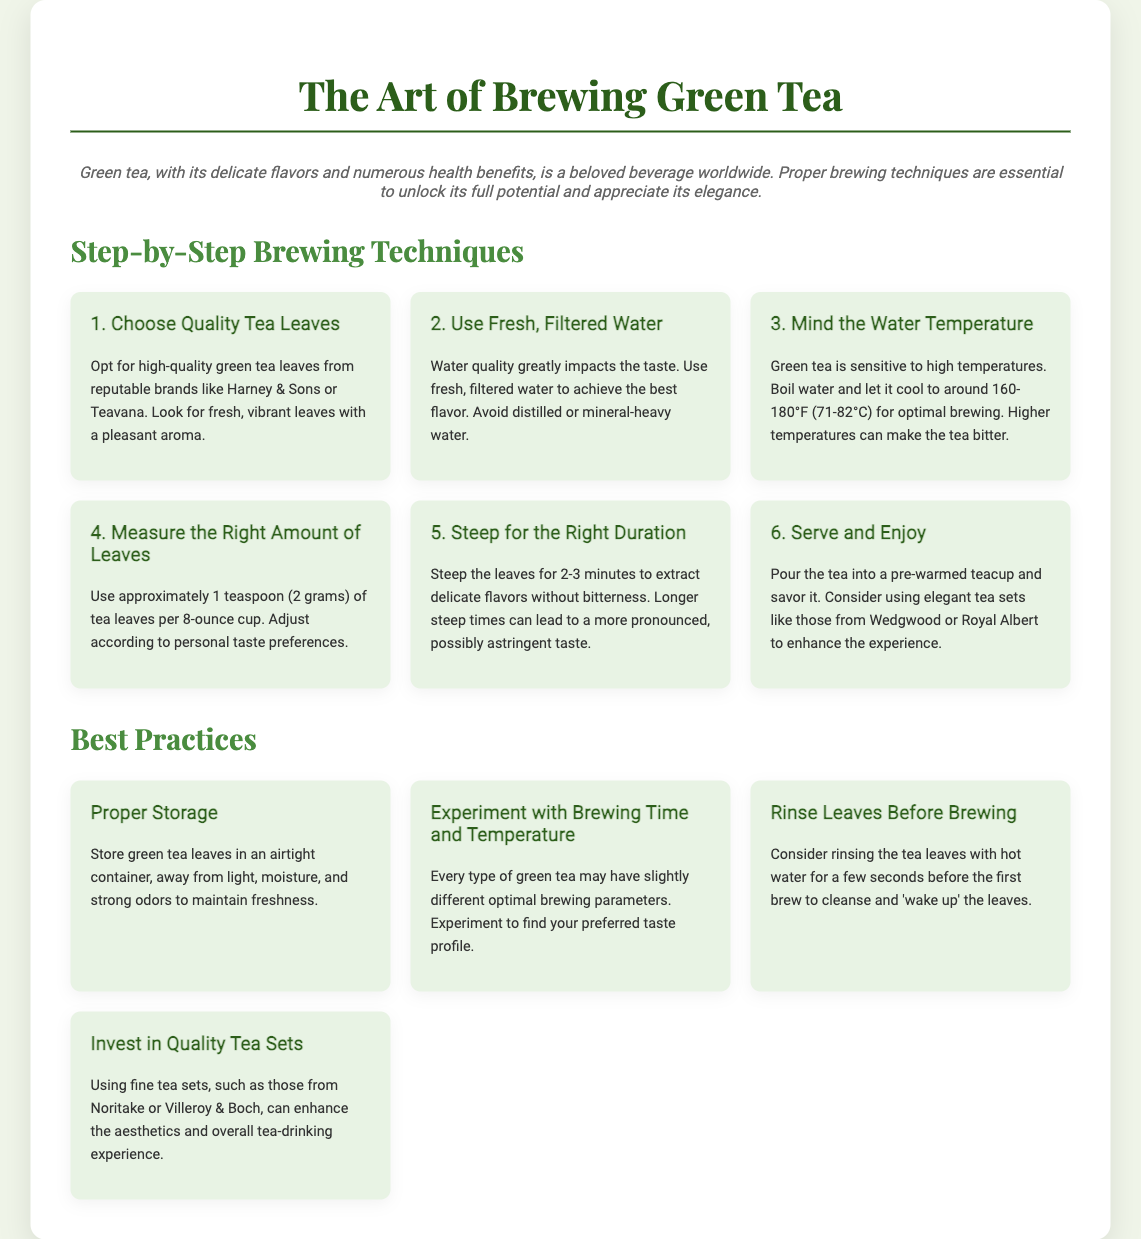What is the ideal water temperature for brewing green tea? The document states that the optimal water temperature for brewing green tea is around 160-180°F (71-82°C).
Answer: 160-180°F (71-82°C) How many grams of tea leaves should be used per 8-ounce cup? According to the document, approximately 1 teaspoon (2 grams) of tea leaves should be used per 8-ounce cup.
Answer: 2 grams What is one brand recommended for quality green tea leaves? The presentation mentions reputable brands such as Harney & Sons or Teavana as options for quality green tea leaves.
Answer: Harney & Sons What should you use to enhance the aesthetics of the tea-drinking experience? The document suggests using fine tea sets, like those from Noritake or Villeroy & Boch, to enhance the overall experience.
Answer: Fine tea sets What is one of the best practices for storing green tea leaves? The document advises storing green tea leaves in an airtight container, away from light, moisture, and strong odors to maintain freshness.
Answer: Airtight container What effect does a longer steep time have on green tea? The document indicates that longer steep times can lead to a more pronounced, possibly astringent taste in green tea.
Answer: Astringent taste What is the purpose of rinsing tea leaves before brewing? Rinsing tea leaves before brewing is suggested to cleanse and 'wake up' the leaves.
Answer: Cleanse and 'wake up' the leaves What key factor greatly impacts the taste of green tea? The document emphasizes that water quality is a significant factor that influences the taste of green tea.
Answer: Water quality 